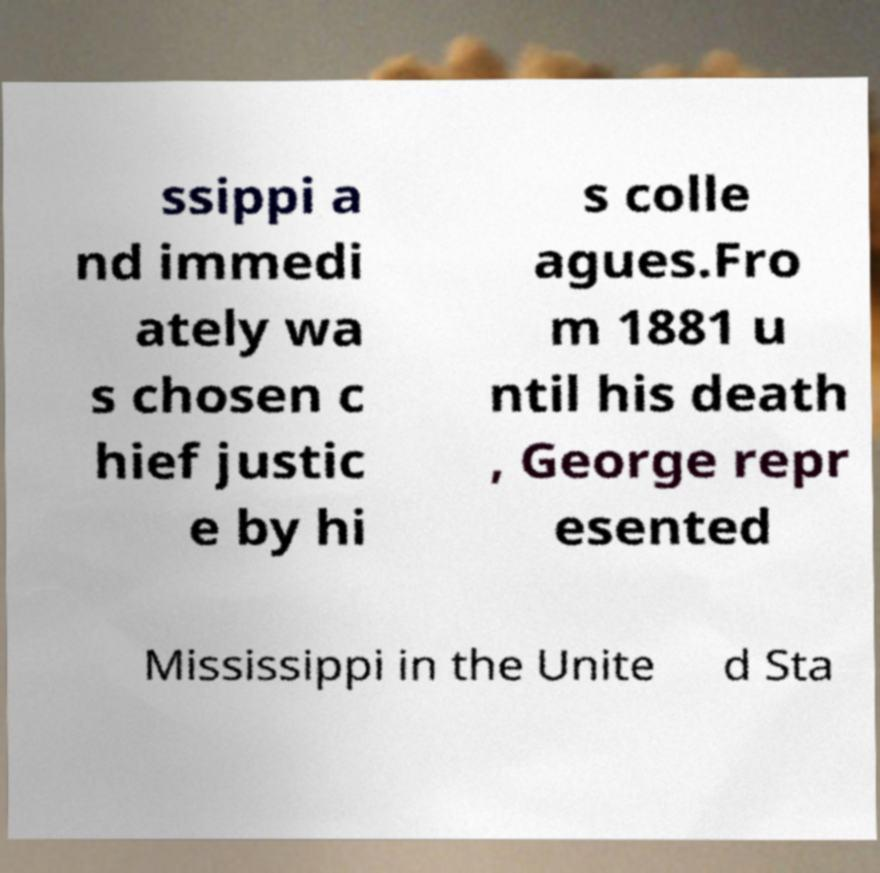For documentation purposes, I need the text within this image transcribed. Could you provide that? ssippi a nd immedi ately wa s chosen c hief justic e by hi s colle agues.Fro m 1881 u ntil his death , George repr esented Mississippi in the Unite d Sta 